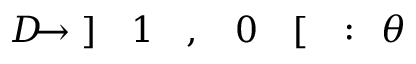<formula> <loc_0><loc_0><loc_500><loc_500>\, \theta \, \colon \, [ \, 0 \, , \, 1 \, ] \, \to \, D \,</formula> 